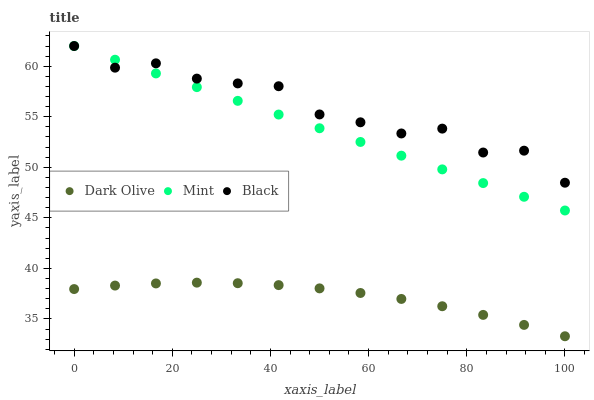Does Dark Olive have the minimum area under the curve?
Answer yes or no. Yes. Does Black have the maximum area under the curve?
Answer yes or no. Yes. Does Mint have the minimum area under the curve?
Answer yes or no. No. Does Mint have the maximum area under the curve?
Answer yes or no. No. Is Mint the smoothest?
Answer yes or no. Yes. Is Black the roughest?
Answer yes or no. Yes. Is Dark Olive the smoothest?
Answer yes or no. No. Is Dark Olive the roughest?
Answer yes or no. No. Does Dark Olive have the lowest value?
Answer yes or no. Yes. Does Mint have the lowest value?
Answer yes or no. No. Does Mint have the highest value?
Answer yes or no. Yes. Does Dark Olive have the highest value?
Answer yes or no. No. Is Dark Olive less than Mint?
Answer yes or no. Yes. Is Black greater than Dark Olive?
Answer yes or no. Yes. Does Black intersect Mint?
Answer yes or no. Yes. Is Black less than Mint?
Answer yes or no. No. Is Black greater than Mint?
Answer yes or no. No. Does Dark Olive intersect Mint?
Answer yes or no. No. 